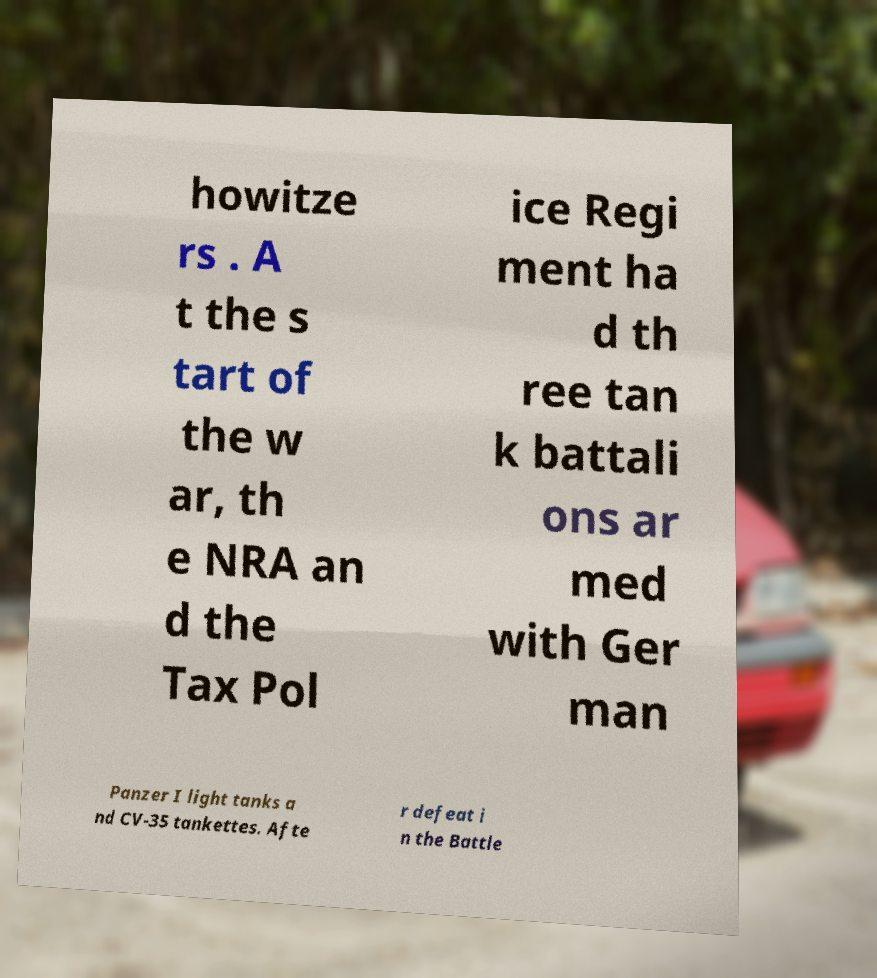Could you extract and type out the text from this image? howitze rs . A t the s tart of the w ar, th e NRA an d the Tax Pol ice Regi ment ha d th ree tan k battali ons ar med with Ger man Panzer I light tanks a nd CV-35 tankettes. Afte r defeat i n the Battle 